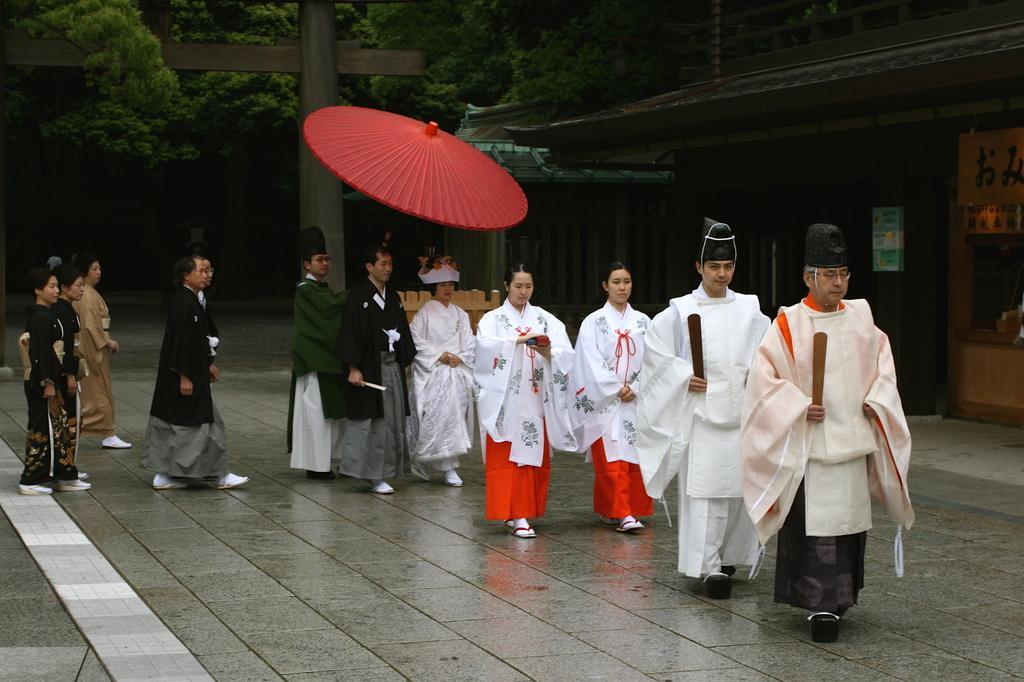Describe this image in one or two sentences. In this image, I can see a group of people walking on the pathway. Among them one person is holding an Asian umbrella. On the right side of the image, I can see houses. In the background, I can see an arch and there are trees. 